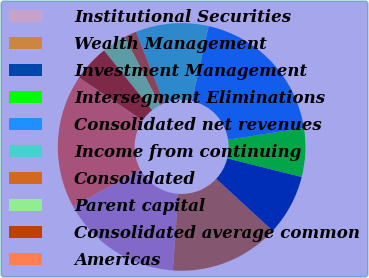Convert chart. <chart><loc_0><loc_0><loc_500><loc_500><pie_chart><fcel>Institutional Securities<fcel>Wealth Management<fcel>Investment Management<fcel>Intersegment Eliminations<fcel>Consolidated net revenues<fcel>Income from continuing<fcel>Consolidated<fcel>Parent capital<fcel>Consolidated average common<fcel>Americas<nl><fcel>15.87%<fcel>14.29%<fcel>7.94%<fcel>6.35%<fcel>19.05%<fcel>9.52%<fcel>1.59%<fcel>3.18%<fcel>4.76%<fcel>17.46%<nl></chart> 